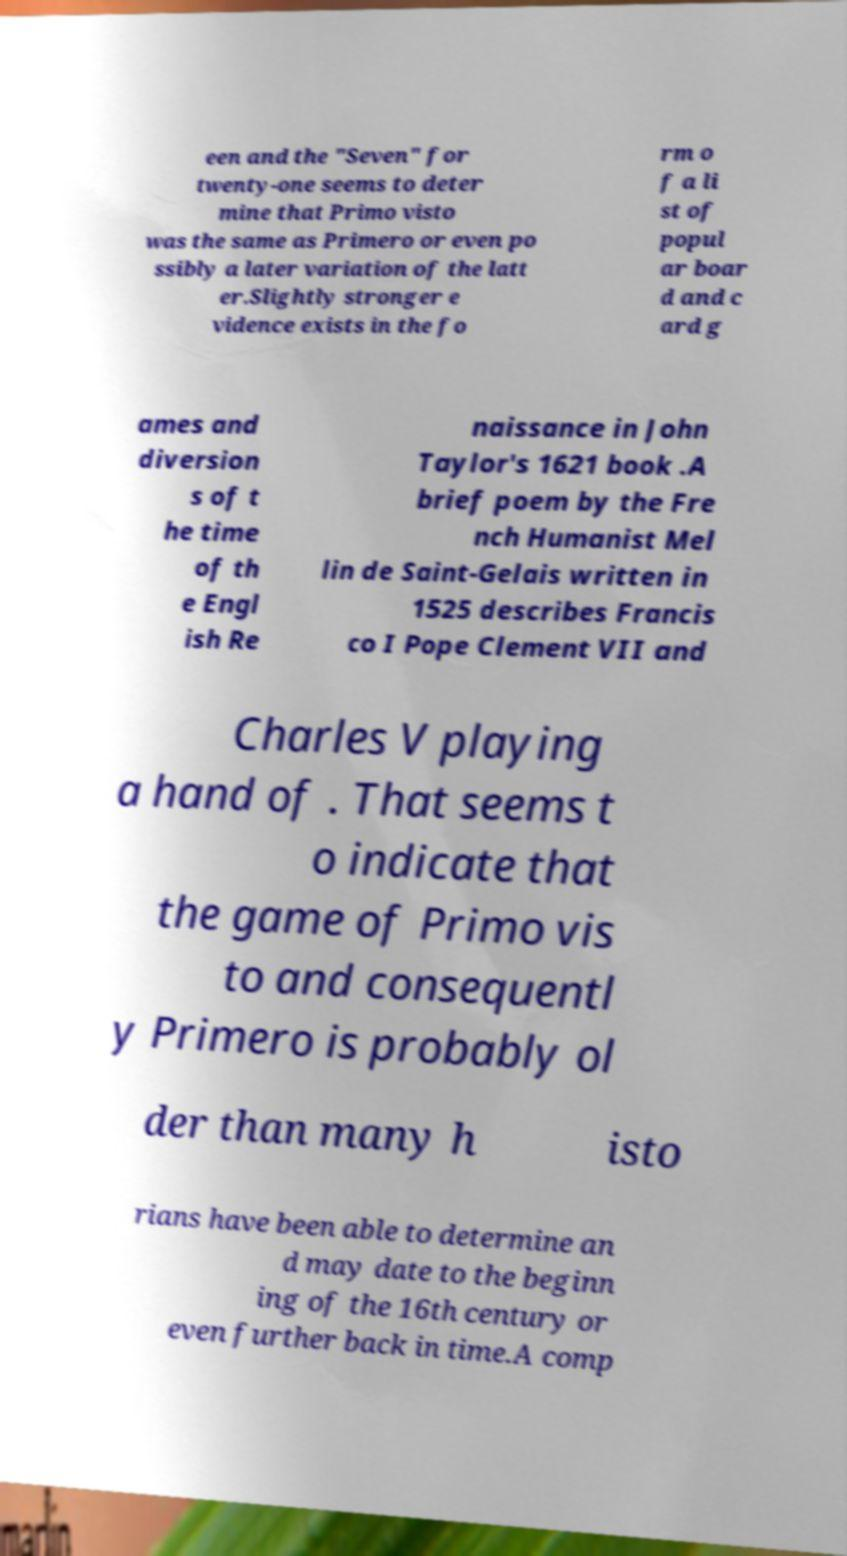Could you extract and type out the text from this image? een and the "Seven" for twenty-one seems to deter mine that Primo visto was the same as Primero or even po ssibly a later variation of the latt er.Slightly stronger e vidence exists in the fo rm o f a li st of popul ar boar d and c ard g ames and diversion s of t he time of th e Engl ish Re naissance in John Taylor's 1621 book .A brief poem by the Fre nch Humanist Mel lin de Saint-Gelais written in 1525 describes Francis co I Pope Clement VII and Charles V playing a hand of . That seems t o indicate that the game of Primo vis to and consequentl y Primero is probably ol der than many h isto rians have been able to determine an d may date to the beginn ing of the 16th century or even further back in time.A comp 